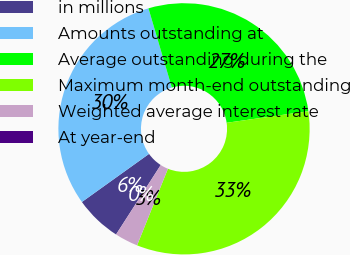Convert chart. <chart><loc_0><loc_0><loc_500><loc_500><pie_chart><fcel>in millions<fcel>Amounts outstanding at<fcel>Average outstanding during the<fcel>Maximum month-end outstanding<fcel>Weighted average interest rate<fcel>At year-end<nl><fcel>6.01%<fcel>30.33%<fcel>27.33%<fcel>33.33%<fcel>3.0%<fcel>0.0%<nl></chart> 